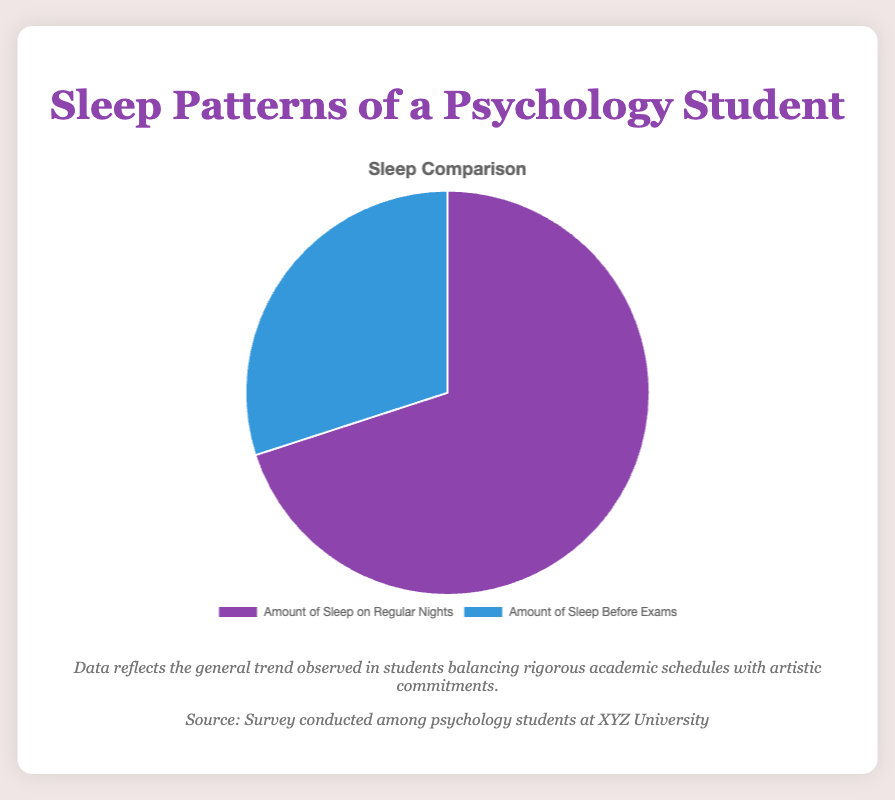How much sleep does the psychology student get before exams compared to regular nights? On the pie chart, the amount of sleep before exams is 30%, and the amount of sleep on regular nights is 70%. These percentages show that the student gets less sleep before exams.
Answer: 30% before exams, 70% on regular nights What is the difference in sleep percentage between regular nights and nights before exams? To find the difference, subtract the percentage of sleep before exams (30%) from the percentage of sleep on regular nights (70%): 70% - 30% = 40%.
Answer: 40% What color represents the amount of sleep on regular nights? By observing the pie chart, we see that the segment representing the amount of sleep on regular nights is colored purple.
Answer: Purple Which category has a smaller percentage of sleep, and by how much? The sleep before exams category has a smaller percentage. To quantify the difference, we subtract the sleep before exams percentage (30%) from the regular nights percentage (70%): 70% - 30% = 40%.
Answer: Sleep before exams, by 40% What does the purple segment in the pie chart represent? The purple segment represents the amount of sleep on regular nights, which constitutes 70% of the total sleep.
Answer: Amount of sleep on regular nights What is the combined percentage of sleep on regular nights and before exams? The pie chart segments add up to represent the whole, i.e., 100%. So, the combined percentage is the sum of both segments: 70% (regular nights) + 30% (before exams) = 100%.
Answer: 100% Which segment is larger in the pie chart, and by what factor? The segment representing the amount of sleep on regular nights (70%) is larger than the one representing sleep before exams (30%). The factor is calculated by dividing the larger percentage by the smaller one: 70% / 30% = 2.33.
Answer: Regular nights, by a factor of 2.33 